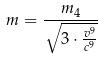<formula> <loc_0><loc_0><loc_500><loc_500>m = \frac { m _ { 4 } } { \sqrt { 3 \cdot \frac { v ^ { 9 } } { c ^ { 9 } } } }</formula> 